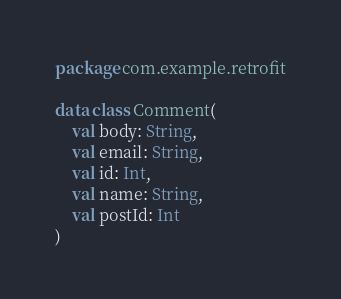<code> <loc_0><loc_0><loc_500><loc_500><_Kotlin_>package com.example.retrofit

data class Comment(
    val body: String,
    val email: String,
    val id: Int,
    val name: String,
    val postId: Int
)
</code> 